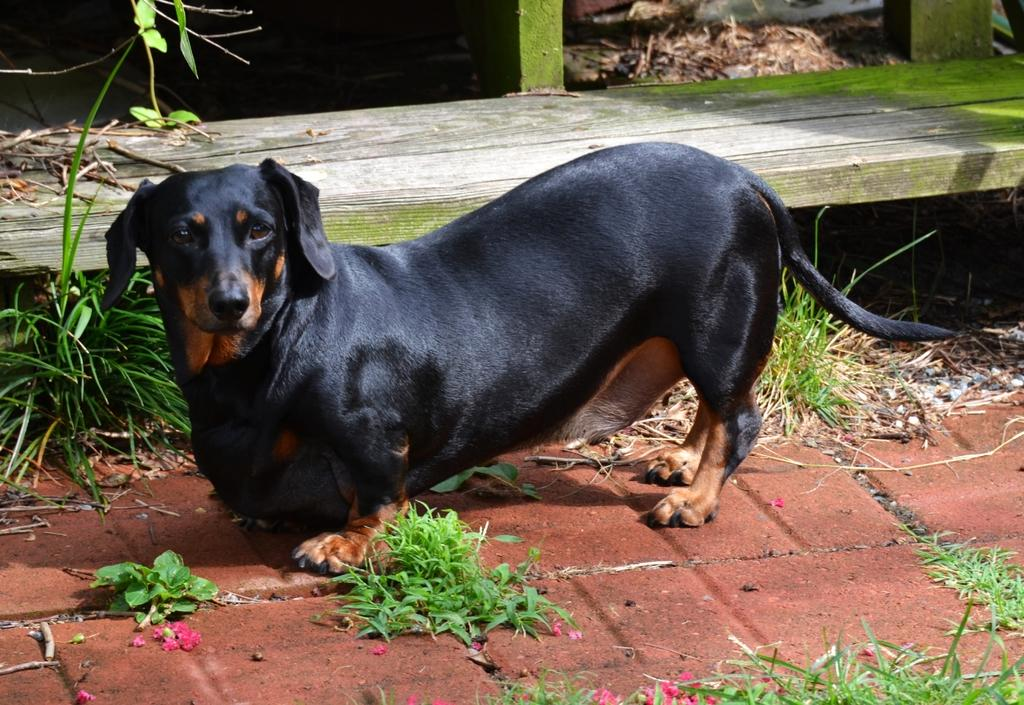What type of animal is in the image? There is a dog in the image. What color is the dog? The dog is black. What can be seen in the background of the image? There is a bench in the background of the image. What type of vegetation is present in the image? There are plants in the image, and they are green. What advice does the parent give to the dog in the image? There is no parent or advice-giving in the image; it features a black dog and a background with a bench and green plants. 